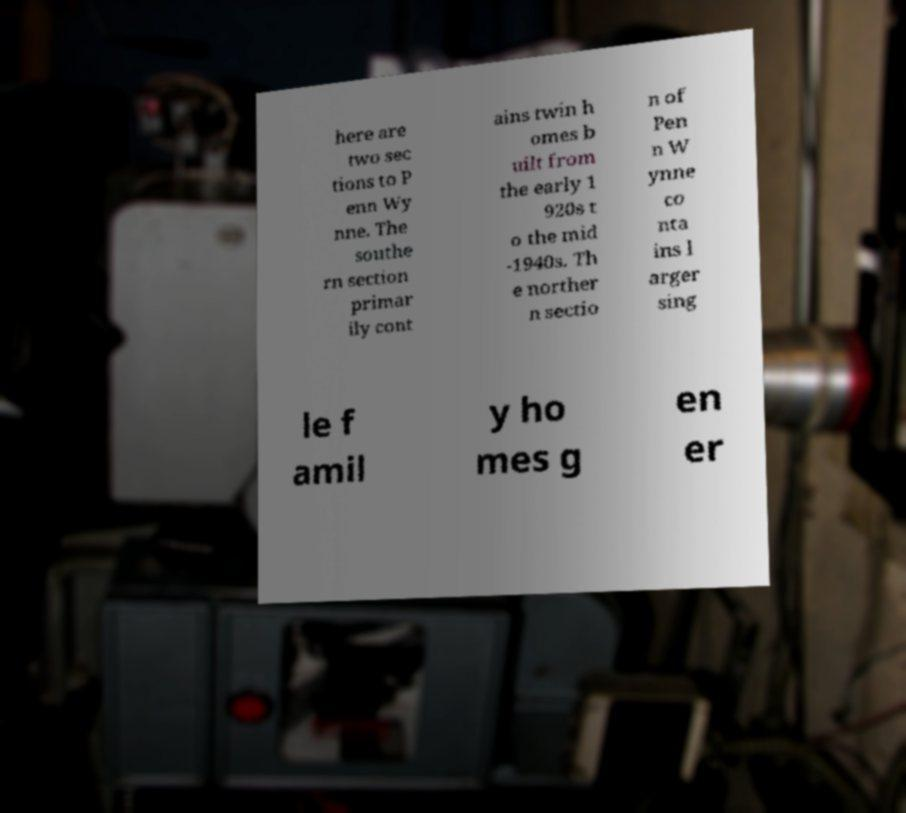Please read and relay the text visible in this image. What does it say? here are two sec tions to P enn Wy nne. The southe rn section primar ily cont ains twin h omes b uilt from the early 1 920s t o the mid -1940s. Th e norther n sectio n of Pen n W ynne co nta ins l arger sing le f amil y ho mes g en er 